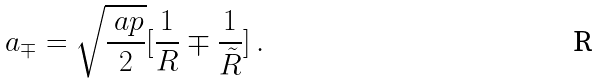Convert formula to latex. <formula><loc_0><loc_0><loc_500><loc_500>a _ { \mp } = \sqrt { \frac { \ a p } { 2 } } [ \frac { 1 } { R } \mp \frac { 1 } { \tilde { R } } ] \, .</formula> 